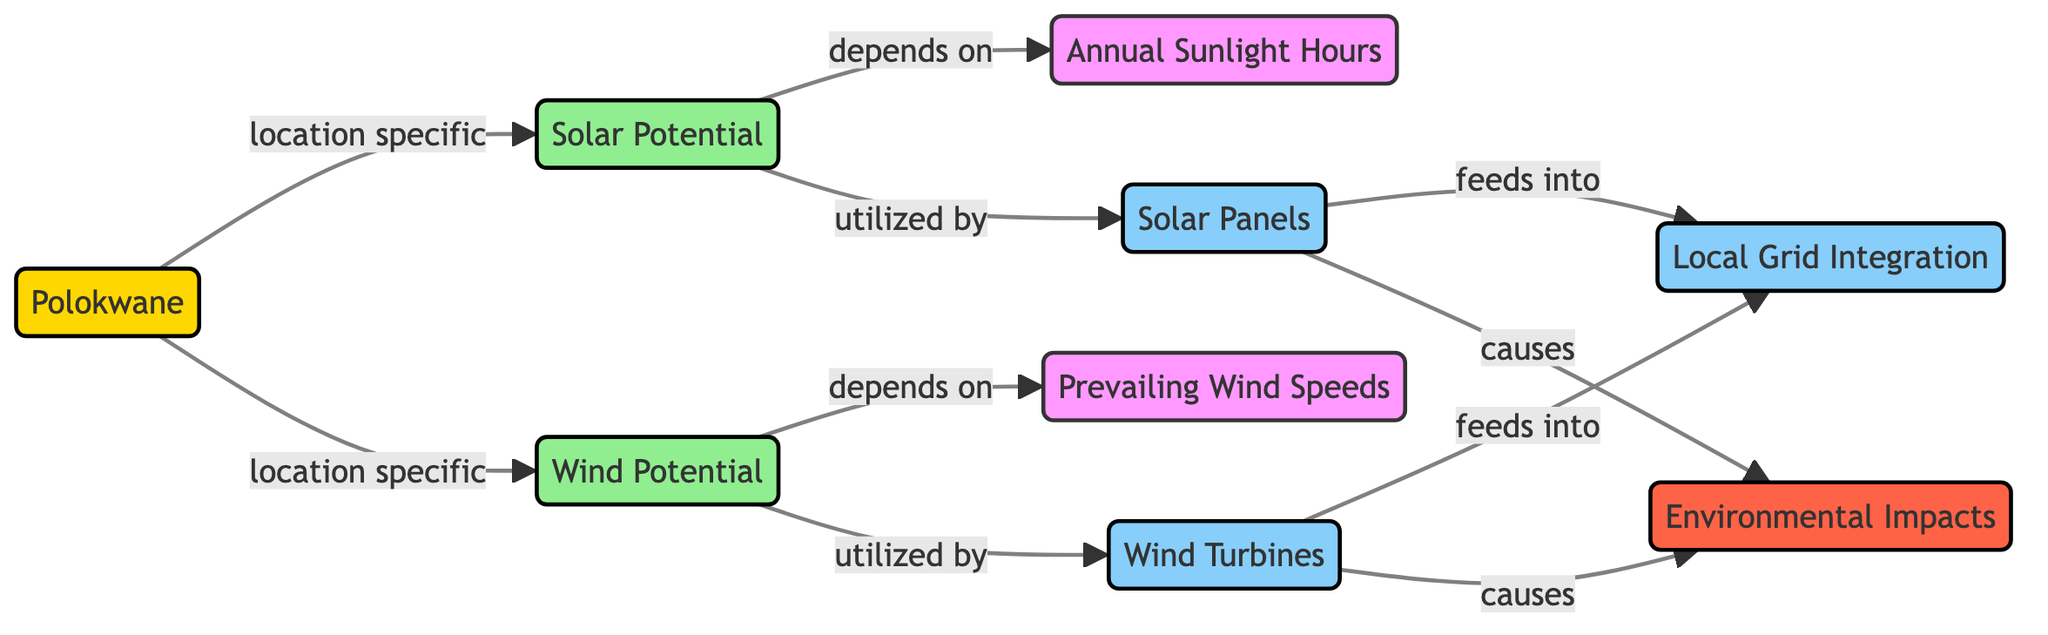What are the two types of potential indicated in the diagram? The diagram clearly identifies two types of potential: "Solar Potential" and "Wind Potential." Both are labeled in their respective nodes.
Answer: Solar Potential and Wind Potential How many infrastructure components are represented in the diagram? The diagram includes three infrastructure components: "Solar Panels," "Wind Turbines," and "Local Grid Integration." By counting the nodes classified as infrastructure, we find a total of three.
Answer: 3 What type of environmental impact is associated with solar panels? In the diagram, it states that solar panels "cause" environmental impacts, as indicated by the flow from solar panels to the environmental impacts node.
Answer: Environmental Impacts Which potential is dependent on annual sunlight hours? The diagram specifies that "Solar Potential" is dependent on "Annual Sunlight Hours," shown by the directional arrow indicating this relationship in the flowchart.
Answer: Solar Potential What feeds into local grid integration? Both "Solar Panels" and "Wind Turbines" feed into the "Local Grid Integration," as depicted by the arrows connecting these nodes to local grid integration.
Answer: Solar Panels and Wind Turbines What is the relationship between prevailing wind speeds and wind potential? The diagram shows that "Wind Potential" depends on "Prevailing Wind Speeds," signifying that changes in wind speeds will affect the wind potential.
Answer: Depends on How does the diagram classify Polokwane in relation to renewable energy potential? The diagram classifies Polokwane as a "location," connecting it to both solar and wind potential, emphasizing its geographic relevance for these resources.
Answer: Location What are the two renewable energy technologies mentioned in the diagram? The diagram mentions "Solar Panels" and "Wind Turbines" as the two technologies utilized for harnessing renewable energy in relation to solar and wind potential.
Answer: Solar Panels and Wind Turbines What does the "Impact" category represent in the diagram? The "Impact" category represents "Environmental Impacts" and indicates that both solar panels and wind turbines have associated environmental consequences, as shown by the causal arrows.
Answer: Environmental Impacts 